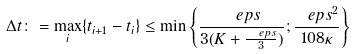<formula> <loc_0><loc_0><loc_500><loc_500>\Delta t \colon = \max _ { i } \{ t _ { i + 1 } - t _ { i } \} \leq \min \left \{ \frac { \ e p s } { 3 ( K + \frac { \ e p s } { 3 } ) } ; \frac { \ e p s ^ { 2 } } { 1 0 8 \kappa } \right \}</formula> 